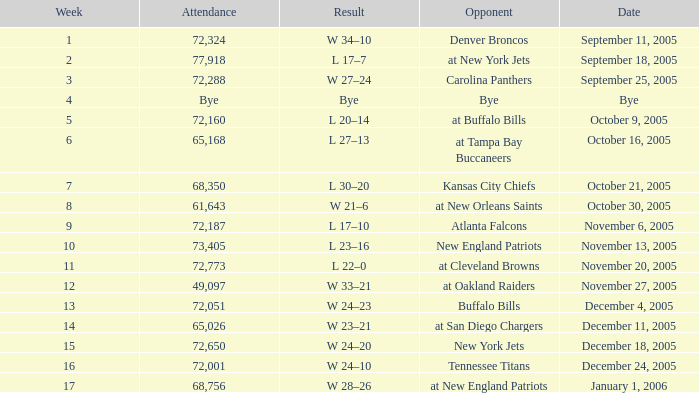In what Week was the Attendance 49,097? 12.0. 